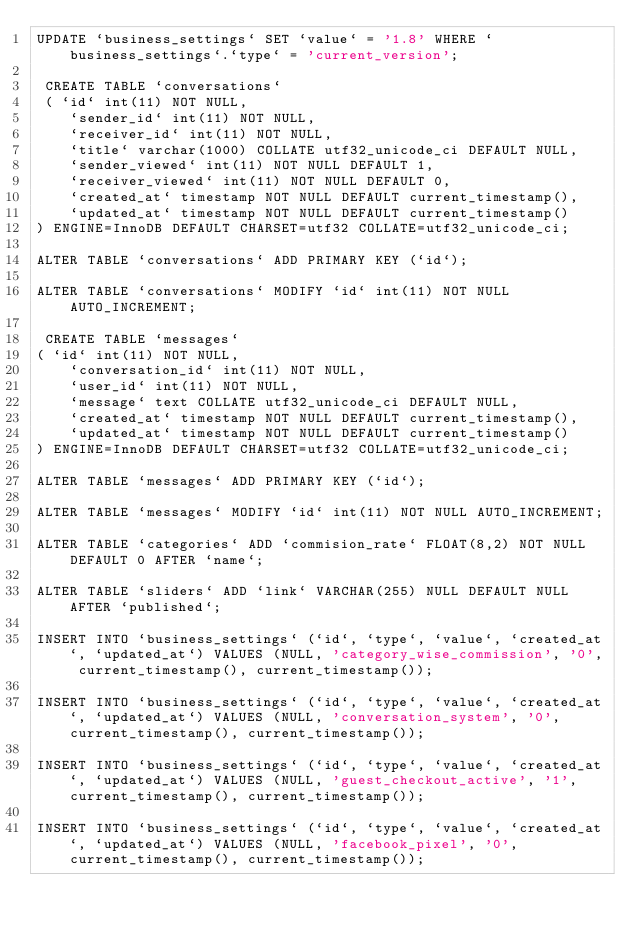<code> <loc_0><loc_0><loc_500><loc_500><_SQL_>UPDATE `business_settings` SET `value` = '1.8' WHERE `business_settings`.`type` = 'current_version';

 CREATE TABLE `conversations`
 ( `id` int(11) NOT NULL,
    `sender_id` int(11) NOT NULL,
    `receiver_id` int(11) NOT NULL,
    `title` varchar(1000) COLLATE utf32_unicode_ci DEFAULT NULL,
    `sender_viewed` int(11) NOT NULL DEFAULT 1,
    `receiver_viewed` int(11) NOT NULL DEFAULT 0,
    `created_at` timestamp NOT NULL DEFAULT current_timestamp(),
    `updated_at` timestamp NOT NULL DEFAULT current_timestamp()
) ENGINE=InnoDB DEFAULT CHARSET=utf32 COLLATE=utf32_unicode_ci;

ALTER TABLE `conversations` ADD PRIMARY KEY (`id`);

ALTER TABLE `conversations` MODIFY `id` int(11) NOT NULL AUTO_INCREMENT;

 CREATE TABLE `messages`
( `id` int(11) NOT NULL,
    `conversation_id` int(11) NOT NULL,
    `user_id` int(11) NOT NULL,
    `message` text COLLATE utf32_unicode_ci DEFAULT NULL,
    `created_at` timestamp NOT NULL DEFAULT current_timestamp(),
    `updated_at` timestamp NOT NULL DEFAULT current_timestamp()
) ENGINE=InnoDB DEFAULT CHARSET=utf32 COLLATE=utf32_unicode_ci;

ALTER TABLE `messages` ADD PRIMARY KEY (`id`);

ALTER TABLE `messages` MODIFY `id` int(11) NOT NULL AUTO_INCREMENT;

ALTER TABLE `categories` ADD `commision_rate` FLOAT(8,2) NOT NULL DEFAULT 0 AFTER `name`;

ALTER TABLE `sliders` ADD `link` VARCHAR(255) NULL DEFAULT NULL AFTER `published`;

INSERT INTO `business_settings` (`id`, `type`, `value`, `created_at`, `updated_at`) VALUES (NULL, 'category_wise_commission', '0', current_timestamp(), current_timestamp());

INSERT INTO `business_settings` (`id`, `type`, `value`, `created_at`, `updated_at`) VALUES (NULL, 'conversation_system', '0', current_timestamp(), current_timestamp());

INSERT INTO `business_settings` (`id`, `type`, `value`, `created_at`, `updated_at`) VALUES (NULL, 'guest_checkout_active', '1', current_timestamp(), current_timestamp());

INSERT INTO `business_settings` (`id`, `type`, `value`, `created_at`, `updated_at`) VALUES (NULL, 'facebook_pixel', '0', current_timestamp(), current_timestamp());
</code> 